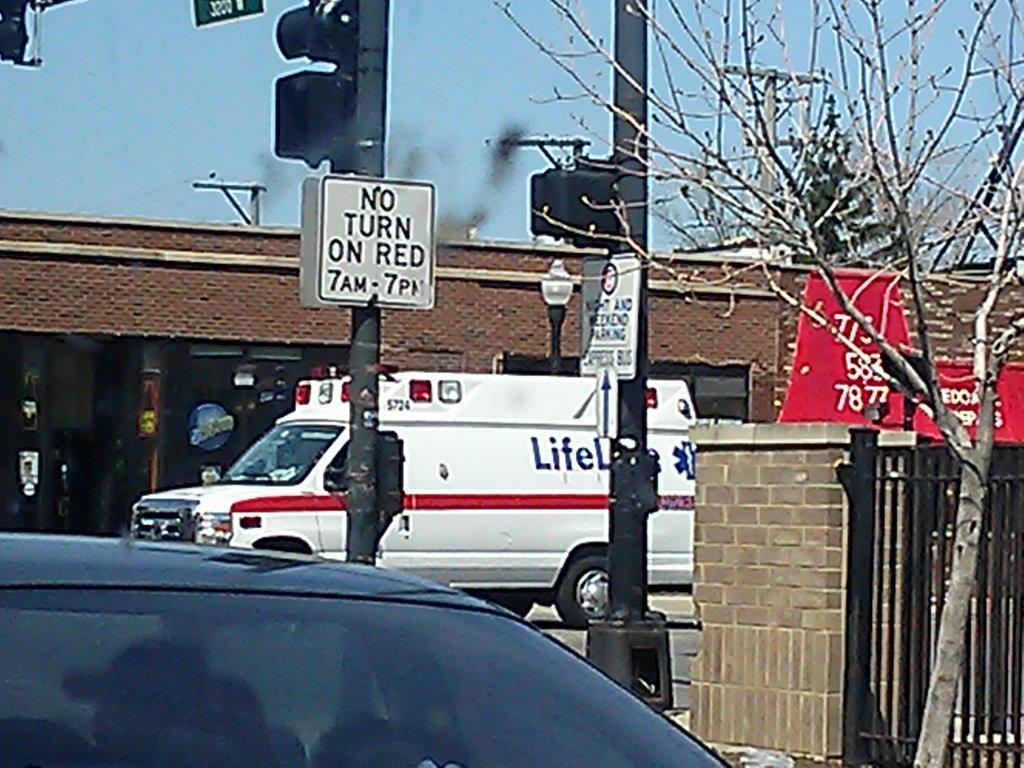How would you summarize this image in a sentence or two? In this image we can see vehicles, caution boards, traffic signals, wall, gate, building, trees and the sky in the background. 